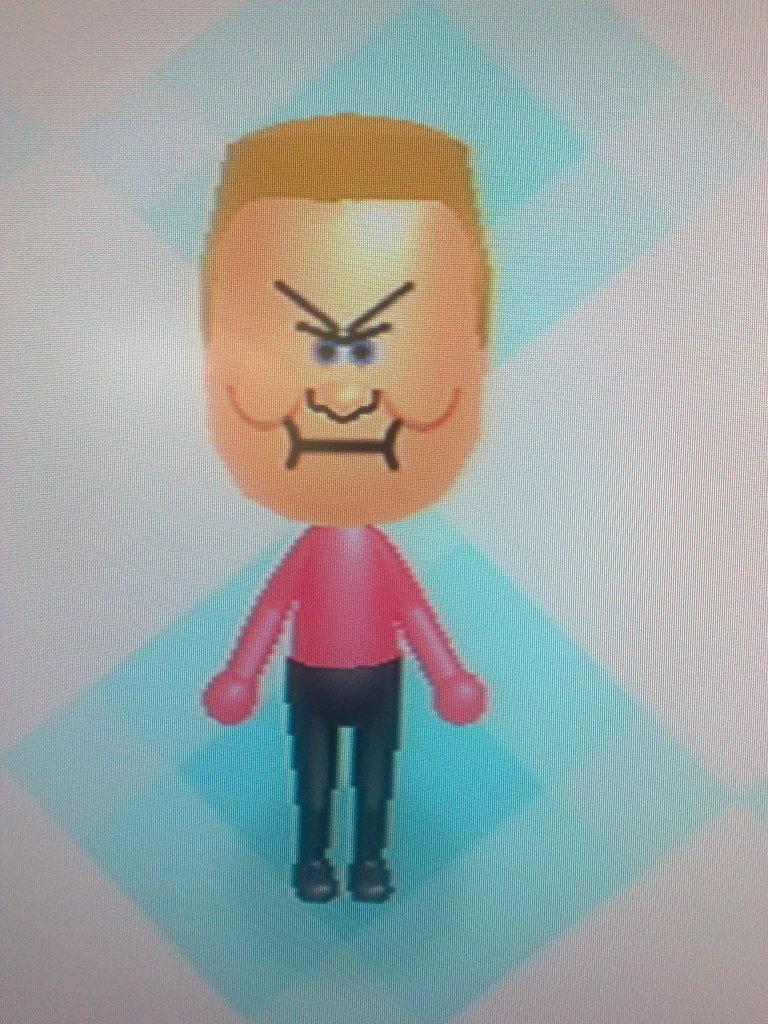How would you summarize this image in a sentence or two? In the middle of the picture we can see cartoon image of a person. 